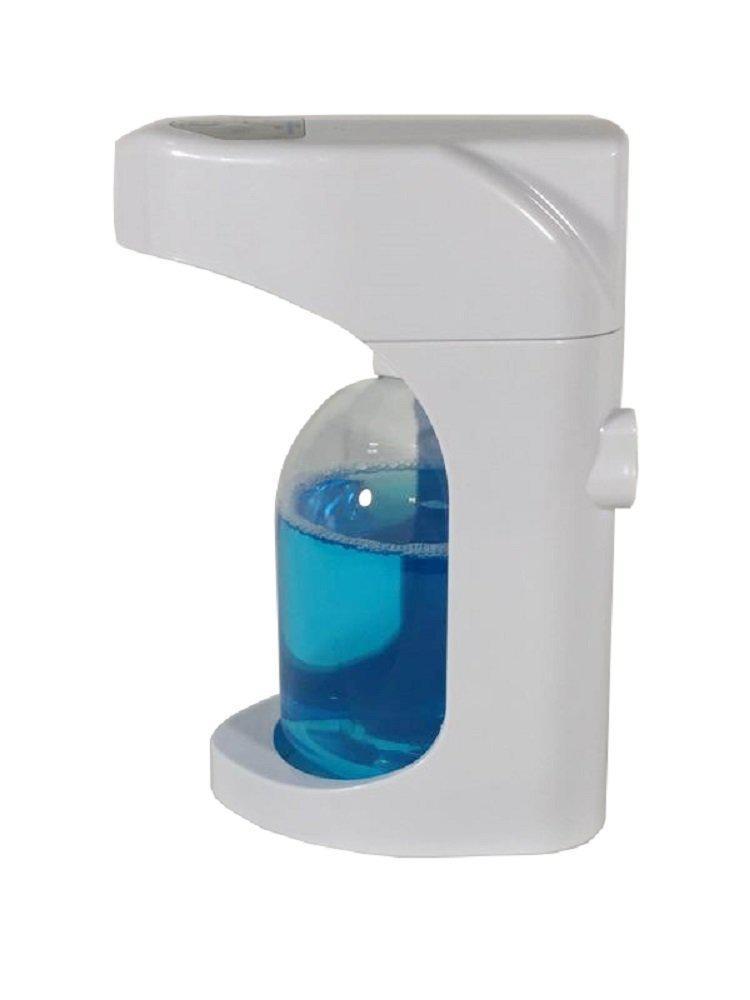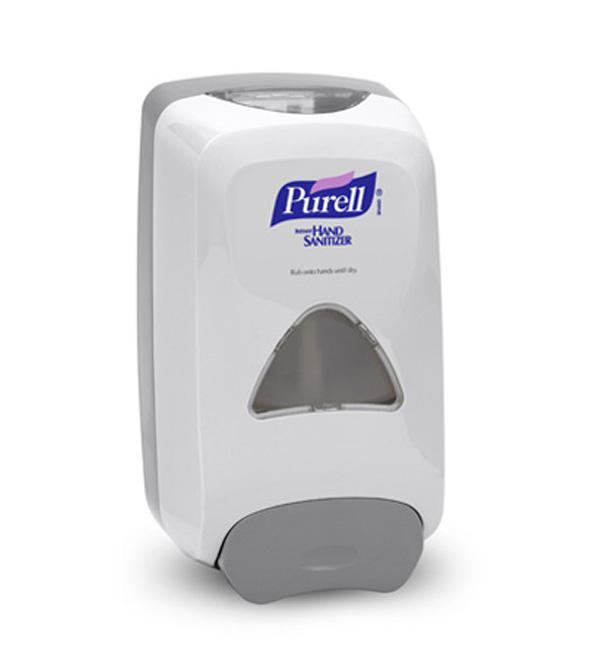The first image is the image on the left, the second image is the image on the right. Assess this claim about the two images: "The image on the right contains a human hand.". Correct or not? Answer yes or no. No. 